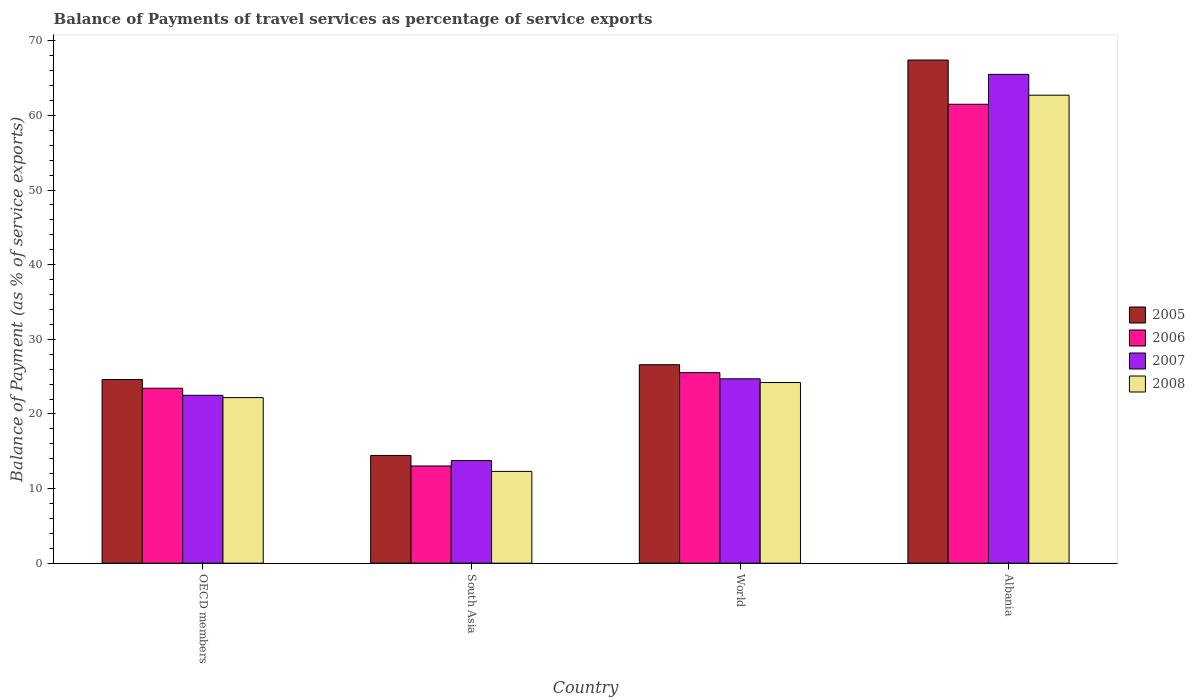How many different coloured bars are there?
Ensure brevity in your answer.  4. How many groups of bars are there?
Keep it short and to the point. 4. Are the number of bars on each tick of the X-axis equal?
Your answer should be very brief. Yes. What is the label of the 1st group of bars from the left?
Give a very brief answer. OECD members. In how many cases, is the number of bars for a given country not equal to the number of legend labels?
Offer a terse response. 0. What is the balance of payments of travel services in 2006 in South Asia?
Your answer should be very brief. 13.03. Across all countries, what is the maximum balance of payments of travel services in 2005?
Offer a very short reply. 67.42. Across all countries, what is the minimum balance of payments of travel services in 2005?
Ensure brevity in your answer.  14.44. In which country was the balance of payments of travel services in 2007 maximum?
Provide a short and direct response. Albania. What is the total balance of payments of travel services in 2007 in the graph?
Provide a short and direct response. 126.44. What is the difference between the balance of payments of travel services in 2005 in Albania and that in OECD members?
Provide a short and direct response. 42.8. What is the difference between the balance of payments of travel services in 2006 in OECD members and the balance of payments of travel services in 2007 in World?
Keep it short and to the point. -1.26. What is the average balance of payments of travel services in 2006 per country?
Your answer should be very brief. 30.87. What is the difference between the balance of payments of travel services of/in 2008 and balance of payments of travel services of/in 2005 in South Asia?
Your answer should be compact. -2.14. In how many countries, is the balance of payments of travel services in 2006 greater than 12 %?
Provide a succinct answer. 4. What is the ratio of the balance of payments of travel services in 2007 in OECD members to that in World?
Ensure brevity in your answer.  0.91. Is the balance of payments of travel services in 2008 in Albania less than that in South Asia?
Your answer should be compact. No. What is the difference between the highest and the second highest balance of payments of travel services in 2006?
Keep it short and to the point. -35.96. What is the difference between the highest and the lowest balance of payments of travel services in 2005?
Offer a terse response. 52.98. What does the 4th bar from the left in World represents?
Keep it short and to the point. 2008. Does the graph contain any zero values?
Your answer should be compact. No. Does the graph contain grids?
Make the answer very short. No. Where does the legend appear in the graph?
Your answer should be compact. Center right. How many legend labels are there?
Provide a short and direct response. 4. How are the legend labels stacked?
Ensure brevity in your answer.  Vertical. What is the title of the graph?
Your answer should be compact. Balance of Payments of travel services as percentage of service exports. What is the label or title of the X-axis?
Provide a short and direct response. Country. What is the label or title of the Y-axis?
Offer a terse response. Balance of Payment (as % of service exports). What is the Balance of Payment (as % of service exports) in 2005 in OECD members?
Make the answer very short. 24.61. What is the Balance of Payment (as % of service exports) of 2006 in OECD members?
Keep it short and to the point. 23.44. What is the Balance of Payment (as % of service exports) in 2007 in OECD members?
Ensure brevity in your answer.  22.5. What is the Balance of Payment (as % of service exports) of 2008 in OECD members?
Your answer should be very brief. 22.19. What is the Balance of Payment (as % of service exports) of 2005 in South Asia?
Your answer should be very brief. 14.44. What is the Balance of Payment (as % of service exports) in 2006 in South Asia?
Give a very brief answer. 13.03. What is the Balance of Payment (as % of service exports) of 2007 in South Asia?
Your response must be concise. 13.75. What is the Balance of Payment (as % of service exports) in 2008 in South Asia?
Make the answer very short. 12.3. What is the Balance of Payment (as % of service exports) of 2005 in World?
Ensure brevity in your answer.  26.59. What is the Balance of Payment (as % of service exports) of 2006 in World?
Keep it short and to the point. 25.53. What is the Balance of Payment (as % of service exports) of 2007 in World?
Ensure brevity in your answer.  24.7. What is the Balance of Payment (as % of service exports) in 2008 in World?
Keep it short and to the point. 24.21. What is the Balance of Payment (as % of service exports) in 2005 in Albania?
Give a very brief answer. 67.42. What is the Balance of Payment (as % of service exports) of 2006 in Albania?
Your response must be concise. 61.49. What is the Balance of Payment (as % of service exports) in 2007 in Albania?
Your response must be concise. 65.49. What is the Balance of Payment (as % of service exports) in 2008 in Albania?
Keep it short and to the point. 62.7. Across all countries, what is the maximum Balance of Payment (as % of service exports) of 2005?
Your answer should be compact. 67.42. Across all countries, what is the maximum Balance of Payment (as % of service exports) of 2006?
Provide a short and direct response. 61.49. Across all countries, what is the maximum Balance of Payment (as % of service exports) of 2007?
Provide a short and direct response. 65.49. Across all countries, what is the maximum Balance of Payment (as % of service exports) of 2008?
Provide a succinct answer. 62.7. Across all countries, what is the minimum Balance of Payment (as % of service exports) in 2005?
Offer a terse response. 14.44. Across all countries, what is the minimum Balance of Payment (as % of service exports) of 2006?
Make the answer very short. 13.03. Across all countries, what is the minimum Balance of Payment (as % of service exports) in 2007?
Your answer should be compact. 13.75. Across all countries, what is the minimum Balance of Payment (as % of service exports) in 2008?
Your answer should be very brief. 12.3. What is the total Balance of Payment (as % of service exports) of 2005 in the graph?
Your answer should be very brief. 133.06. What is the total Balance of Payment (as % of service exports) of 2006 in the graph?
Offer a very short reply. 123.49. What is the total Balance of Payment (as % of service exports) in 2007 in the graph?
Your answer should be compact. 126.44. What is the total Balance of Payment (as % of service exports) in 2008 in the graph?
Your response must be concise. 121.4. What is the difference between the Balance of Payment (as % of service exports) of 2005 in OECD members and that in South Asia?
Make the answer very short. 10.17. What is the difference between the Balance of Payment (as % of service exports) in 2006 in OECD members and that in South Asia?
Provide a succinct answer. 10.41. What is the difference between the Balance of Payment (as % of service exports) in 2007 in OECD members and that in South Asia?
Offer a very short reply. 8.75. What is the difference between the Balance of Payment (as % of service exports) in 2008 in OECD members and that in South Asia?
Provide a short and direct response. 9.89. What is the difference between the Balance of Payment (as % of service exports) of 2005 in OECD members and that in World?
Your response must be concise. -1.98. What is the difference between the Balance of Payment (as % of service exports) of 2006 in OECD members and that in World?
Provide a succinct answer. -2.09. What is the difference between the Balance of Payment (as % of service exports) of 2007 in OECD members and that in World?
Ensure brevity in your answer.  -2.21. What is the difference between the Balance of Payment (as % of service exports) in 2008 in OECD members and that in World?
Provide a short and direct response. -2.02. What is the difference between the Balance of Payment (as % of service exports) of 2005 in OECD members and that in Albania?
Provide a succinct answer. -42.8. What is the difference between the Balance of Payment (as % of service exports) in 2006 in OECD members and that in Albania?
Provide a succinct answer. -38.05. What is the difference between the Balance of Payment (as % of service exports) in 2007 in OECD members and that in Albania?
Ensure brevity in your answer.  -43. What is the difference between the Balance of Payment (as % of service exports) in 2008 in OECD members and that in Albania?
Provide a short and direct response. -40.52. What is the difference between the Balance of Payment (as % of service exports) in 2005 in South Asia and that in World?
Provide a succinct answer. -12.16. What is the difference between the Balance of Payment (as % of service exports) of 2006 in South Asia and that in World?
Provide a succinct answer. -12.5. What is the difference between the Balance of Payment (as % of service exports) in 2007 in South Asia and that in World?
Give a very brief answer. -10.95. What is the difference between the Balance of Payment (as % of service exports) of 2008 in South Asia and that in World?
Ensure brevity in your answer.  -11.91. What is the difference between the Balance of Payment (as % of service exports) of 2005 in South Asia and that in Albania?
Offer a terse response. -52.98. What is the difference between the Balance of Payment (as % of service exports) in 2006 in South Asia and that in Albania?
Give a very brief answer. -48.46. What is the difference between the Balance of Payment (as % of service exports) in 2007 in South Asia and that in Albania?
Ensure brevity in your answer.  -51.74. What is the difference between the Balance of Payment (as % of service exports) in 2008 in South Asia and that in Albania?
Your answer should be very brief. -50.4. What is the difference between the Balance of Payment (as % of service exports) of 2005 in World and that in Albania?
Your answer should be very brief. -40.82. What is the difference between the Balance of Payment (as % of service exports) of 2006 in World and that in Albania?
Keep it short and to the point. -35.96. What is the difference between the Balance of Payment (as % of service exports) in 2007 in World and that in Albania?
Your response must be concise. -40.79. What is the difference between the Balance of Payment (as % of service exports) in 2008 in World and that in Albania?
Provide a short and direct response. -38.5. What is the difference between the Balance of Payment (as % of service exports) of 2005 in OECD members and the Balance of Payment (as % of service exports) of 2006 in South Asia?
Your response must be concise. 11.58. What is the difference between the Balance of Payment (as % of service exports) of 2005 in OECD members and the Balance of Payment (as % of service exports) of 2007 in South Asia?
Your answer should be compact. 10.86. What is the difference between the Balance of Payment (as % of service exports) of 2005 in OECD members and the Balance of Payment (as % of service exports) of 2008 in South Asia?
Ensure brevity in your answer.  12.31. What is the difference between the Balance of Payment (as % of service exports) of 2006 in OECD members and the Balance of Payment (as % of service exports) of 2007 in South Asia?
Offer a very short reply. 9.69. What is the difference between the Balance of Payment (as % of service exports) of 2006 in OECD members and the Balance of Payment (as % of service exports) of 2008 in South Asia?
Keep it short and to the point. 11.14. What is the difference between the Balance of Payment (as % of service exports) of 2007 in OECD members and the Balance of Payment (as % of service exports) of 2008 in South Asia?
Offer a terse response. 10.19. What is the difference between the Balance of Payment (as % of service exports) in 2005 in OECD members and the Balance of Payment (as % of service exports) in 2006 in World?
Give a very brief answer. -0.92. What is the difference between the Balance of Payment (as % of service exports) in 2005 in OECD members and the Balance of Payment (as % of service exports) in 2007 in World?
Ensure brevity in your answer.  -0.09. What is the difference between the Balance of Payment (as % of service exports) in 2005 in OECD members and the Balance of Payment (as % of service exports) in 2008 in World?
Offer a terse response. 0.4. What is the difference between the Balance of Payment (as % of service exports) in 2006 in OECD members and the Balance of Payment (as % of service exports) in 2007 in World?
Your response must be concise. -1.26. What is the difference between the Balance of Payment (as % of service exports) in 2006 in OECD members and the Balance of Payment (as % of service exports) in 2008 in World?
Make the answer very short. -0.77. What is the difference between the Balance of Payment (as % of service exports) of 2007 in OECD members and the Balance of Payment (as % of service exports) of 2008 in World?
Your answer should be compact. -1.71. What is the difference between the Balance of Payment (as % of service exports) in 2005 in OECD members and the Balance of Payment (as % of service exports) in 2006 in Albania?
Your answer should be compact. -36.88. What is the difference between the Balance of Payment (as % of service exports) in 2005 in OECD members and the Balance of Payment (as % of service exports) in 2007 in Albania?
Offer a terse response. -40.88. What is the difference between the Balance of Payment (as % of service exports) in 2005 in OECD members and the Balance of Payment (as % of service exports) in 2008 in Albania?
Your response must be concise. -38.09. What is the difference between the Balance of Payment (as % of service exports) in 2006 in OECD members and the Balance of Payment (as % of service exports) in 2007 in Albania?
Your response must be concise. -42.05. What is the difference between the Balance of Payment (as % of service exports) of 2006 in OECD members and the Balance of Payment (as % of service exports) of 2008 in Albania?
Ensure brevity in your answer.  -39.26. What is the difference between the Balance of Payment (as % of service exports) in 2007 in OECD members and the Balance of Payment (as % of service exports) in 2008 in Albania?
Offer a very short reply. -40.21. What is the difference between the Balance of Payment (as % of service exports) of 2005 in South Asia and the Balance of Payment (as % of service exports) of 2006 in World?
Your answer should be very brief. -11.09. What is the difference between the Balance of Payment (as % of service exports) of 2005 in South Asia and the Balance of Payment (as % of service exports) of 2007 in World?
Provide a short and direct response. -10.27. What is the difference between the Balance of Payment (as % of service exports) of 2005 in South Asia and the Balance of Payment (as % of service exports) of 2008 in World?
Provide a short and direct response. -9.77. What is the difference between the Balance of Payment (as % of service exports) of 2006 in South Asia and the Balance of Payment (as % of service exports) of 2007 in World?
Provide a succinct answer. -11.68. What is the difference between the Balance of Payment (as % of service exports) in 2006 in South Asia and the Balance of Payment (as % of service exports) in 2008 in World?
Ensure brevity in your answer.  -11.18. What is the difference between the Balance of Payment (as % of service exports) in 2007 in South Asia and the Balance of Payment (as % of service exports) in 2008 in World?
Your answer should be compact. -10.46. What is the difference between the Balance of Payment (as % of service exports) of 2005 in South Asia and the Balance of Payment (as % of service exports) of 2006 in Albania?
Ensure brevity in your answer.  -47.05. What is the difference between the Balance of Payment (as % of service exports) of 2005 in South Asia and the Balance of Payment (as % of service exports) of 2007 in Albania?
Make the answer very short. -51.05. What is the difference between the Balance of Payment (as % of service exports) in 2005 in South Asia and the Balance of Payment (as % of service exports) in 2008 in Albania?
Your response must be concise. -48.27. What is the difference between the Balance of Payment (as % of service exports) of 2006 in South Asia and the Balance of Payment (as % of service exports) of 2007 in Albania?
Give a very brief answer. -52.47. What is the difference between the Balance of Payment (as % of service exports) in 2006 in South Asia and the Balance of Payment (as % of service exports) in 2008 in Albania?
Provide a short and direct response. -49.68. What is the difference between the Balance of Payment (as % of service exports) of 2007 in South Asia and the Balance of Payment (as % of service exports) of 2008 in Albania?
Your response must be concise. -48.95. What is the difference between the Balance of Payment (as % of service exports) in 2005 in World and the Balance of Payment (as % of service exports) in 2006 in Albania?
Your answer should be compact. -34.9. What is the difference between the Balance of Payment (as % of service exports) in 2005 in World and the Balance of Payment (as % of service exports) in 2007 in Albania?
Your answer should be compact. -38.9. What is the difference between the Balance of Payment (as % of service exports) of 2005 in World and the Balance of Payment (as % of service exports) of 2008 in Albania?
Your answer should be very brief. -36.11. What is the difference between the Balance of Payment (as % of service exports) in 2006 in World and the Balance of Payment (as % of service exports) in 2007 in Albania?
Provide a succinct answer. -39.97. What is the difference between the Balance of Payment (as % of service exports) of 2006 in World and the Balance of Payment (as % of service exports) of 2008 in Albania?
Your response must be concise. -37.18. What is the difference between the Balance of Payment (as % of service exports) in 2007 in World and the Balance of Payment (as % of service exports) in 2008 in Albania?
Your answer should be compact. -38. What is the average Balance of Payment (as % of service exports) of 2005 per country?
Make the answer very short. 33.26. What is the average Balance of Payment (as % of service exports) in 2006 per country?
Make the answer very short. 30.87. What is the average Balance of Payment (as % of service exports) in 2007 per country?
Make the answer very short. 31.61. What is the average Balance of Payment (as % of service exports) in 2008 per country?
Your answer should be compact. 30.35. What is the difference between the Balance of Payment (as % of service exports) of 2005 and Balance of Payment (as % of service exports) of 2006 in OECD members?
Give a very brief answer. 1.17. What is the difference between the Balance of Payment (as % of service exports) in 2005 and Balance of Payment (as % of service exports) in 2007 in OECD members?
Your answer should be very brief. 2.12. What is the difference between the Balance of Payment (as % of service exports) of 2005 and Balance of Payment (as % of service exports) of 2008 in OECD members?
Offer a terse response. 2.42. What is the difference between the Balance of Payment (as % of service exports) in 2006 and Balance of Payment (as % of service exports) in 2007 in OECD members?
Provide a succinct answer. 0.95. What is the difference between the Balance of Payment (as % of service exports) in 2006 and Balance of Payment (as % of service exports) in 2008 in OECD members?
Your response must be concise. 1.25. What is the difference between the Balance of Payment (as % of service exports) of 2007 and Balance of Payment (as % of service exports) of 2008 in OECD members?
Provide a succinct answer. 0.31. What is the difference between the Balance of Payment (as % of service exports) in 2005 and Balance of Payment (as % of service exports) in 2006 in South Asia?
Provide a short and direct response. 1.41. What is the difference between the Balance of Payment (as % of service exports) in 2005 and Balance of Payment (as % of service exports) in 2007 in South Asia?
Your response must be concise. 0.69. What is the difference between the Balance of Payment (as % of service exports) of 2005 and Balance of Payment (as % of service exports) of 2008 in South Asia?
Offer a terse response. 2.14. What is the difference between the Balance of Payment (as % of service exports) in 2006 and Balance of Payment (as % of service exports) in 2007 in South Asia?
Offer a terse response. -0.72. What is the difference between the Balance of Payment (as % of service exports) in 2006 and Balance of Payment (as % of service exports) in 2008 in South Asia?
Keep it short and to the point. 0.73. What is the difference between the Balance of Payment (as % of service exports) in 2007 and Balance of Payment (as % of service exports) in 2008 in South Asia?
Keep it short and to the point. 1.45. What is the difference between the Balance of Payment (as % of service exports) in 2005 and Balance of Payment (as % of service exports) in 2006 in World?
Your response must be concise. 1.07. What is the difference between the Balance of Payment (as % of service exports) of 2005 and Balance of Payment (as % of service exports) of 2007 in World?
Give a very brief answer. 1.89. What is the difference between the Balance of Payment (as % of service exports) of 2005 and Balance of Payment (as % of service exports) of 2008 in World?
Offer a terse response. 2.39. What is the difference between the Balance of Payment (as % of service exports) of 2006 and Balance of Payment (as % of service exports) of 2007 in World?
Provide a succinct answer. 0.82. What is the difference between the Balance of Payment (as % of service exports) of 2006 and Balance of Payment (as % of service exports) of 2008 in World?
Your answer should be very brief. 1.32. What is the difference between the Balance of Payment (as % of service exports) of 2007 and Balance of Payment (as % of service exports) of 2008 in World?
Keep it short and to the point. 0.5. What is the difference between the Balance of Payment (as % of service exports) of 2005 and Balance of Payment (as % of service exports) of 2006 in Albania?
Your response must be concise. 5.92. What is the difference between the Balance of Payment (as % of service exports) of 2005 and Balance of Payment (as % of service exports) of 2007 in Albania?
Your answer should be very brief. 1.92. What is the difference between the Balance of Payment (as % of service exports) in 2005 and Balance of Payment (as % of service exports) in 2008 in Albania?
Make the answer very short. 4.71. What is the difference between the Balance of Payment (as % of service exports) of 2006 and Balance of Payment (as % of service exports) of 2007 in Albania?
Ensure brevity in your answer.  -4. What is the difference between the Balance of Payment (as % of service exports) of 2006 and Balance of Payment (as % of service exports) of 2008 in Albania?
Provide a short and direct response. -1.21. What is the difference between the Balance of Payment (as % of service exports) of 2007 and Balance of Payment (as % of service exports) of 2008 in Albania?
Provide a short and direct response. 2.79. What is the ratio of the Balance of Payment (as % of service exports) of 2005 in OECD members to that in South Asia?
Your answer should be very brief. 1.7. What is the ratio of the Balance of Payment (as % of service exports) of 2006 in OECD members to that in South Asia?
Your response must be concise. 1.8. What is the ratio of the Balance of Payment (as % of service exports) in 2007 in OECD members to that in South Asia?
Your answer should be compact. 1.64. What is the ratio of the Balance of Payment (as % of service exports) in 2008 in OECD members to that in South Asia?
Give a very brief answer. 1.8. What is the ratio of the Balance of Payment (as % of service exports) in 2005 in OECD members to that in World?
Provide a short and direct response. 0.93. What is the ratio of the Balance of Payment (as % of service exports) of 2006 in OECD members to that in World?
Offer a very short reply. 0.92. What is the ratio of the Balance of Payment (as % of service exports) of 2007 in OECD members to that in World?
Provide a succinct answer. 0.91. What is the ratio of the Balance of Payment (as % of service exports) of 2008 in OECD members to that in World?
Ensure brevity in your answer.  0.92. What is the ratio of the Balance of Payment (as % of service exports) in 2005 in OECD members to that in Albania?
Make the answer very short. 0.37. What is the ratio of the Balance of Payment (as % of service exports) of 2006 in OECD members to that in Albania?
Ensure brevity in your answer.  0.38. What is the ratio of the Balance of Payment (as % of service exports) of 2007 in OECD members to that in Albania?
Give a very brief answer. 0.34. What is the ratio of the Balance of Payment (as % of service exports) in 2008 in OECD members to that in Albania?
Ensure brevity in your answer.  0.35. What is the ratio of the Balance of Payment (as % of service exports) in 2005 in South Asia to that in World?
Make the answer very short. 0.54. What is the ratio of the Balance of Payment (as % of service exports) in 2006 in South Asia to that in World?
Your answer should be compact. 0.51. What is the ratio of the Balance of Payment (as % of service exports) in 2007 in South Asia to that in World?
Give a very brief answer. 0.56. What is the ratio of the Balance of Payment (as % of service exports) in 2008 in South Asia to that in World?
Give a very brief answer. 0.51. What is the ratio of the Balance of Payment (as % of service exports) of 2005 in South Asia to that in Albania?
Your answer should be compact. 0.21. What is the ratio of the Balance of Payment (as % of service exports) of 2006 in South Asia to that in Albania?
Give a very brief answer. 0.21. What is the ratio of the Balance of Payment (as % of service exports) in 2007 in South Asia to that in Albania?
Your response must be concise. 0.21. What is the ratio of the Balance of Payment (as % of service exports) in 2008 in South Asia to that in Albania?
Make the answer very short. 0.2. What is the ratio of the Balance of Payment (as % of service exports) in 2005 in World to that in Albania?
Make the answer very short. 0.39. What is the ratio of the Balance of Payment (as % of service exports) of 2006 in World to that in Albania?
Give a very brief answer. 0.42. What is the ratio of the Balance of Payment (as % of service exports) of 2007 in World to that in Albania?
Provide a short and direct response. 0.38. What is the ratio of the Balance of Payment (as % of service exports) of 2008 in World to that in Albania?
Ensure brevity in your answer.  0.39. What is the difference between the highest and the second highest Balance of Payment (as % of service exports) in 2005?
Provide a short and direct response. 40.82. What is the difference between the highest and the second highest Balance of Payment (as % of service exports) of 2006?
Give a very brief answer. 35.96. What is the difference between the highest and the second highest Balance of Payment (as % of service exports) of 2007?
Your answer should be very brief. 40.79. What is the difference between the highest and the second highest Balance of Payment (as % of service exports) in 2008?
Ensure brevity in your answer.  38.5. What is the difference between the highest and the lowest Balance of Payment (as % of service exports) in 2005?
Your answer should be compact. 52.98. What is the difference between the highest and the lowest Balance of Payment (as % of service exports) of 2006?
Your answer should be compact. 48.46. What is the difference between the highest and the lowest Balance of Payment (as % of service exports) of 2007?
Your answer should be very brief. 51.74. What is the difference between the highest and the lowest Balance of Payment (as % of service exports) of 2008?
Offer a very short reply. 50.4. 